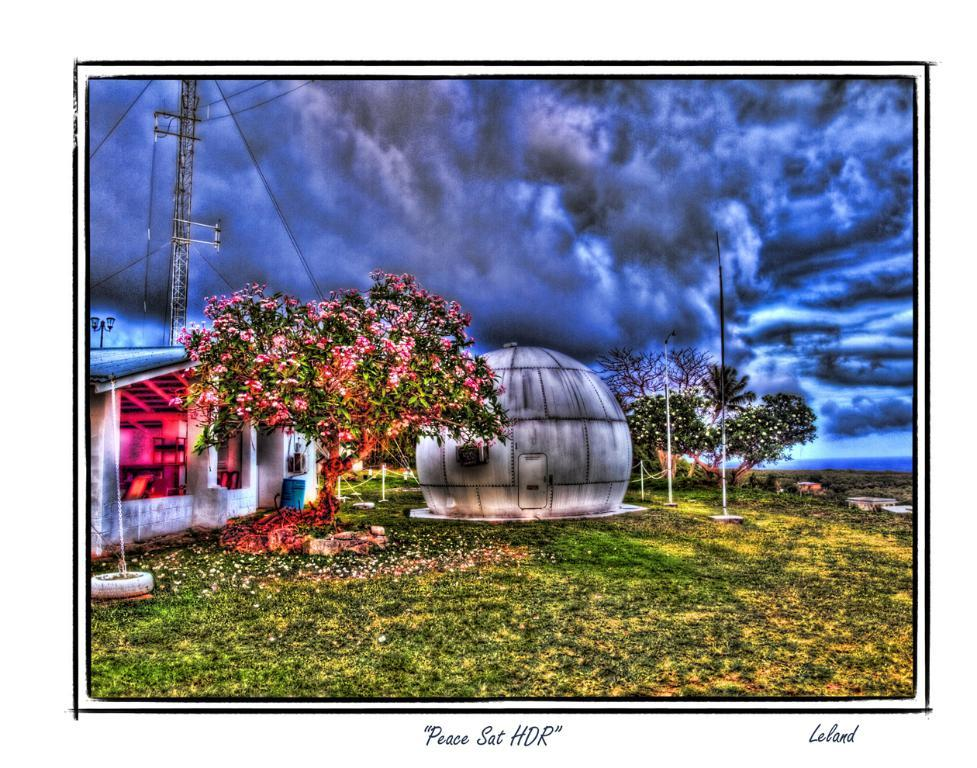What type of visual is the image? The image is a poster. What type of terrain is depicted at the bottom of the image? There is grass at the bottom of the image. What type of structure is present in the image? There is a house in the image. What type of vegetation is present in the image? There are trees in the image. What type of architectural feature is present in the image? There is a tower in the image. What is visible in the sky in the image? There is a sky with clouds in the image. Where is the bell located in the image? There is no bell present in the image. What type of fuel is used to power the volcano in the image? There is no volcano present in the image. 